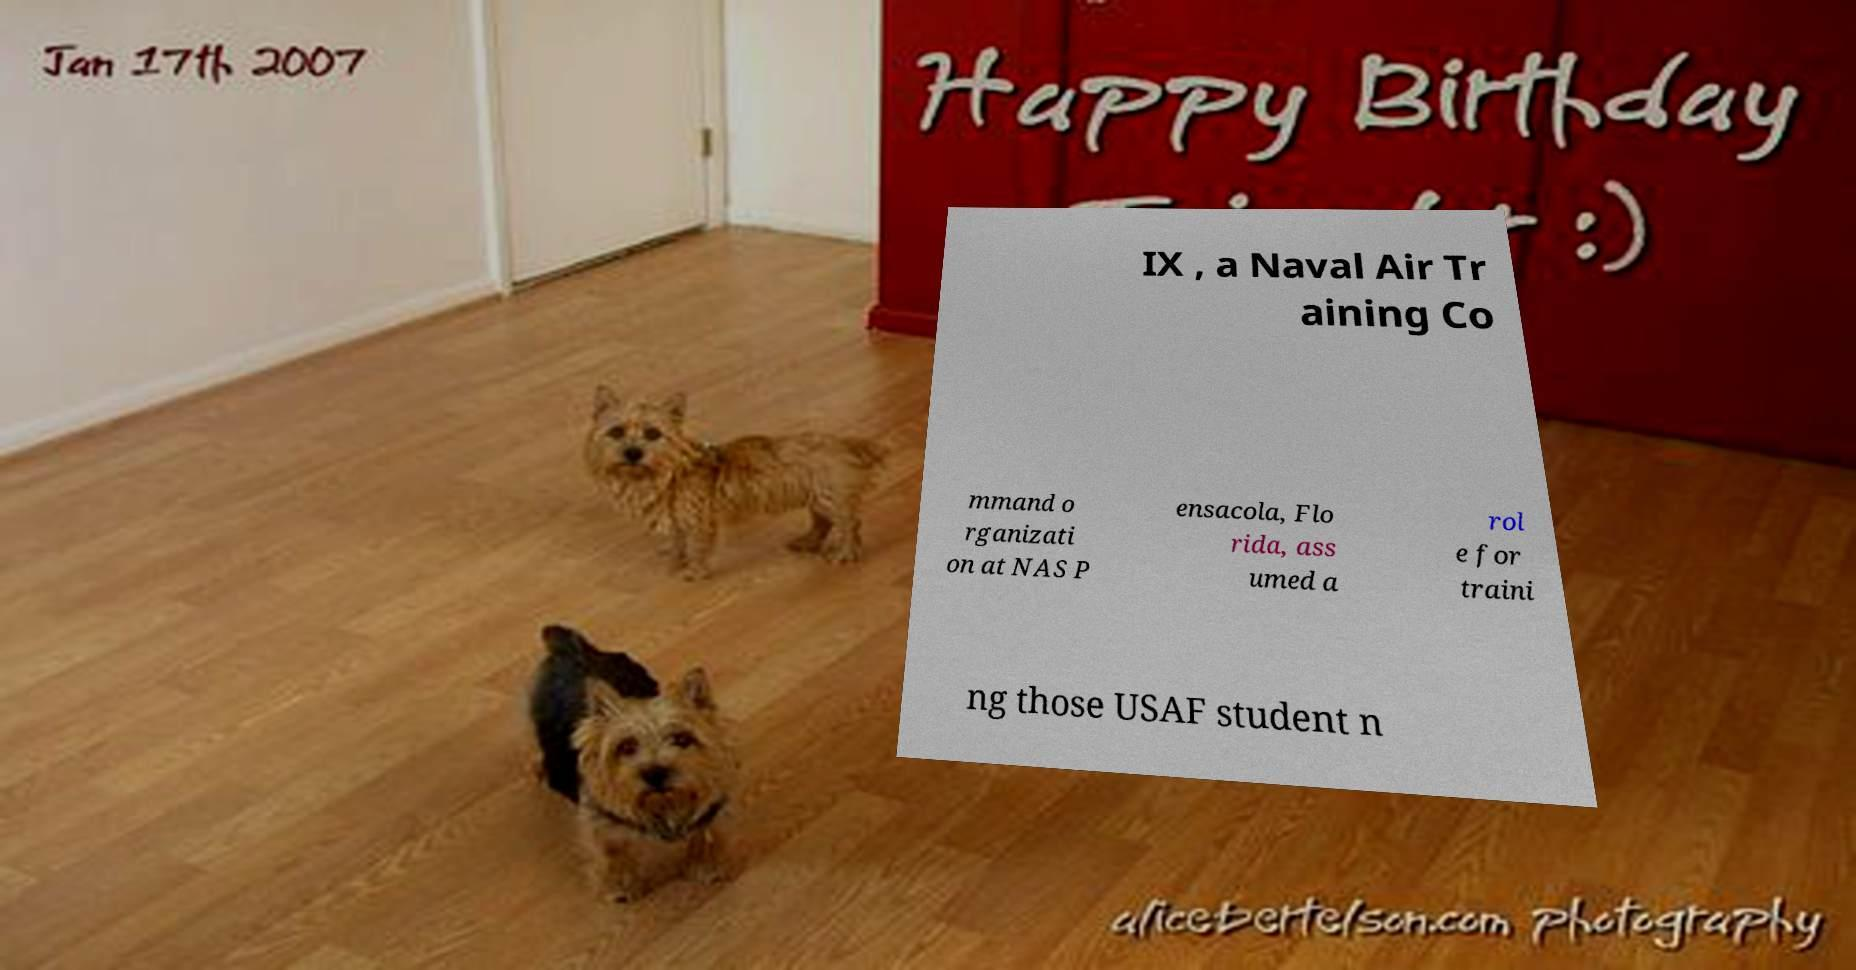Could you extract and type out the text from this image? IX , a Naval Air Tr aining Co mmand o rganizati on at NAS P ensacola, Flo rida, ass umed a rol e for traini ng those USAF student n 